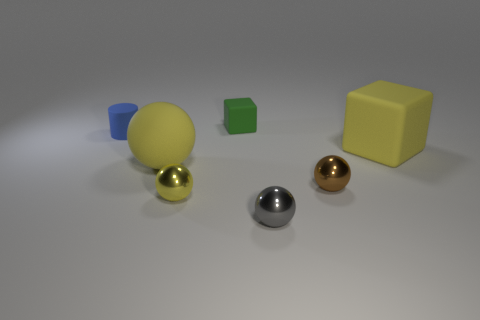What material is the yellow sphere that is in front of the yellow sphere that is to the left of the tiny yellow thing made of?
Make the answer very short. Metal. Is the number of small gray metal objects behind the small green thing greater than the number of tiny brown metal spheres?
Make the answer very short. No. Are there any tiny gray cylinders that have the same material as the small green thing?
Provide a succinct answer. No. There is a large rubber object left of the tiny brown ball; does it have the same shape as the blue thing?
Make the answer very short. No. How many small shiny things are behind the green matte thing behind the yellow rubber object that is left of the brown sphere?
Offer a very short reply. 0. Is the number of rubber things that are on the left side of the green matte object less than the number of gray metal objects to the left of the small blue cylinder?
Ensure brevity in your answer.  No. What color is the other matte object that is the same shape as the small brown object?
Keep it short and to the point. Yellow. How big is the yellow shiny object?
Make the answer very short. Small. What number of green things have the same size as the brown shiny sphere?
Keep it short and to the point. 1. Is the small matte cylinder the same color as the large rubber block?
Keep it short and to the point. No. 